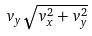Convert formula to latex. <formula><loc_0><loc_0><loc_500><loc_500>v _ { y } \sqrt { v _ { x } ^ { 2 } + v _ { y } ^ { 2 } }</formula> 